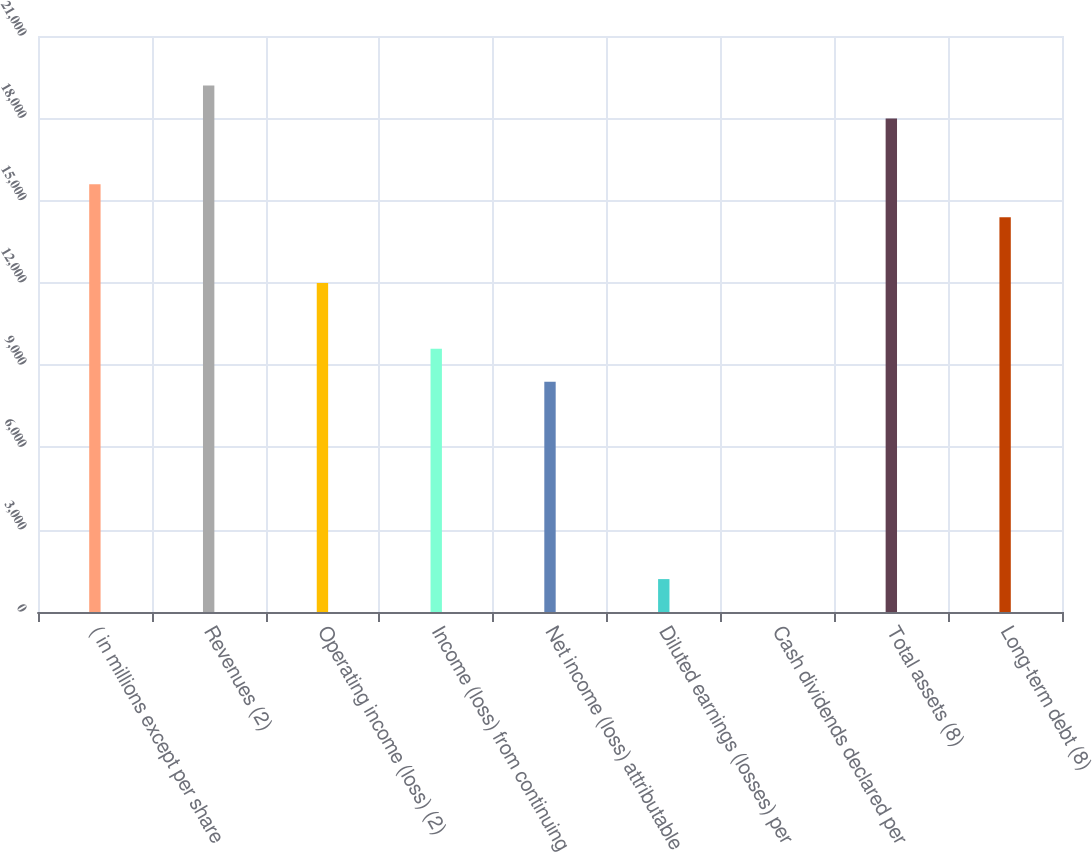<chart> <loc_0><loc_0><loc_500><loc_500><bar_chart><fcel>( in millions except per share<fcel>Revenues (2)<fcel>Operating income (loss) (2)<fcel>Income (loss) from continuing<fcel>Net income (loss) attributable<fcel>Diluted earnings (losses) per<fcel>Cash dividends declared per<fcel>Total assets (8)<fcel>Long-term debt (8)<nl><fcel>15593.5<fcel>19191.9<fcel>11995<fcel>9596.08<fcel>8396.6<fcel>1199.72<fcel>0.24<fcel>17992.4<fcel>14394<nl></chart> 